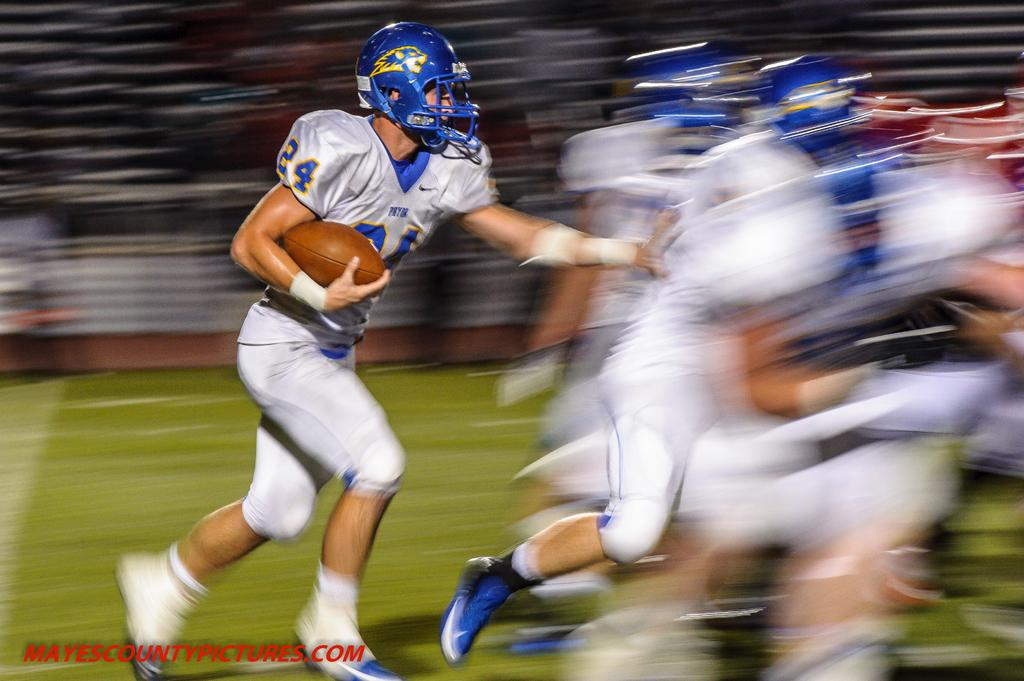What is the person in the image doing? The person in the image is running. What sport does the person in the image play? The person in the image is a rugby player. What protective gear is the rugby player wearing? The rugby player is wearing a blue helmet. What can be seen in front of the rugby player? There are other players in front of the rugby player. What type of soda is the rugby player holding in the image? There is no soda present in the image; the rugby player is running and wearing a blue helmet. Can you see a gun in the image? No, there is no gun present in the image. 